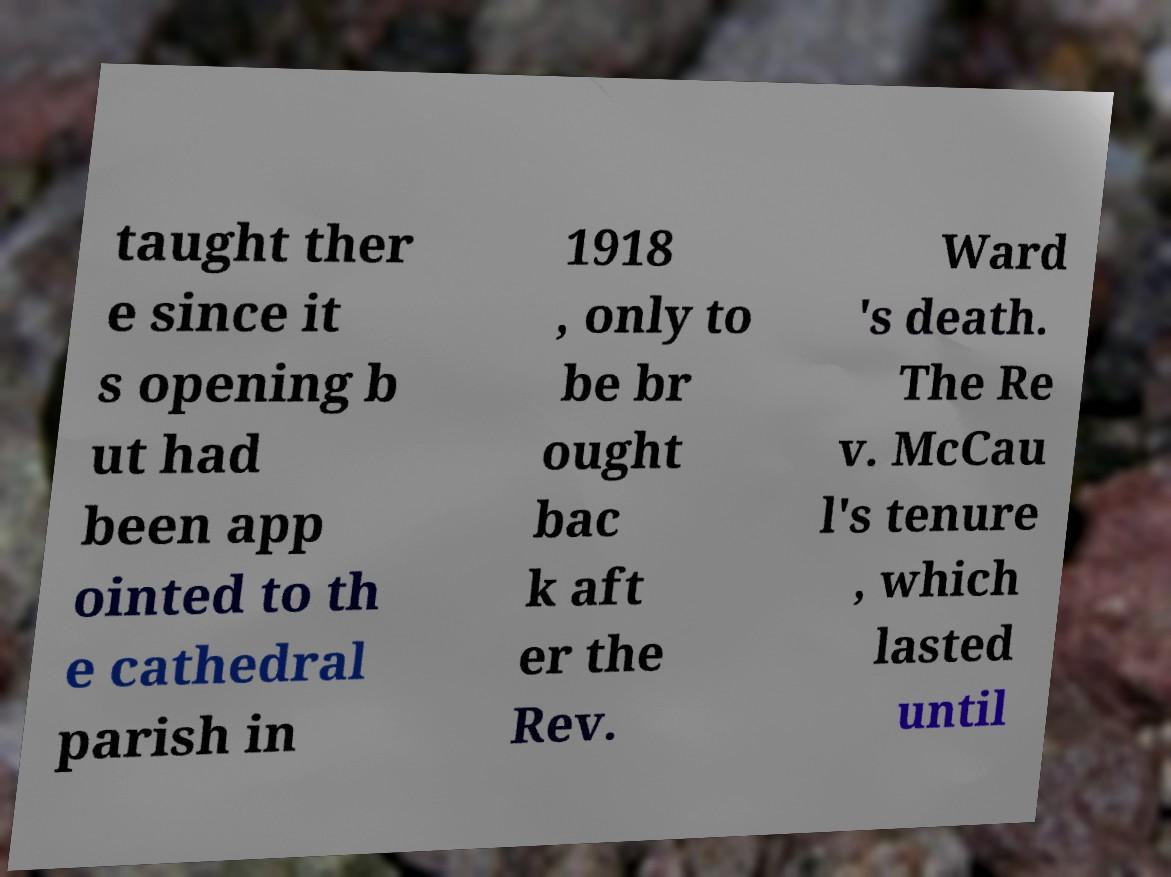For documentation purposes, I need the text within this image transcribed. Could you provide that? taught ther e since it s opening b ut had been app ointed to th e cathedral parish in 1918 , only to be br ought bac k aft er the Rev. Ward 's death. The Re v. McCau l's tenure , which lasted until 